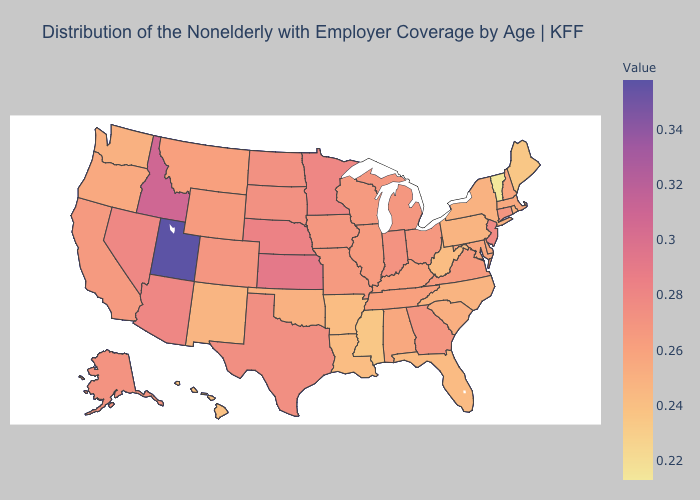Does Hawaii have the lowest value in the West?
Keep it brief. Yes. Which states have the highest value in the USA?
Quick response, please. Utah. Does Mississippi have the lowest value in the South?
Answer briefly. Yes. Among the states that border Arkansas , which have the lowest value?
Write a very short answer. Mississippi. 